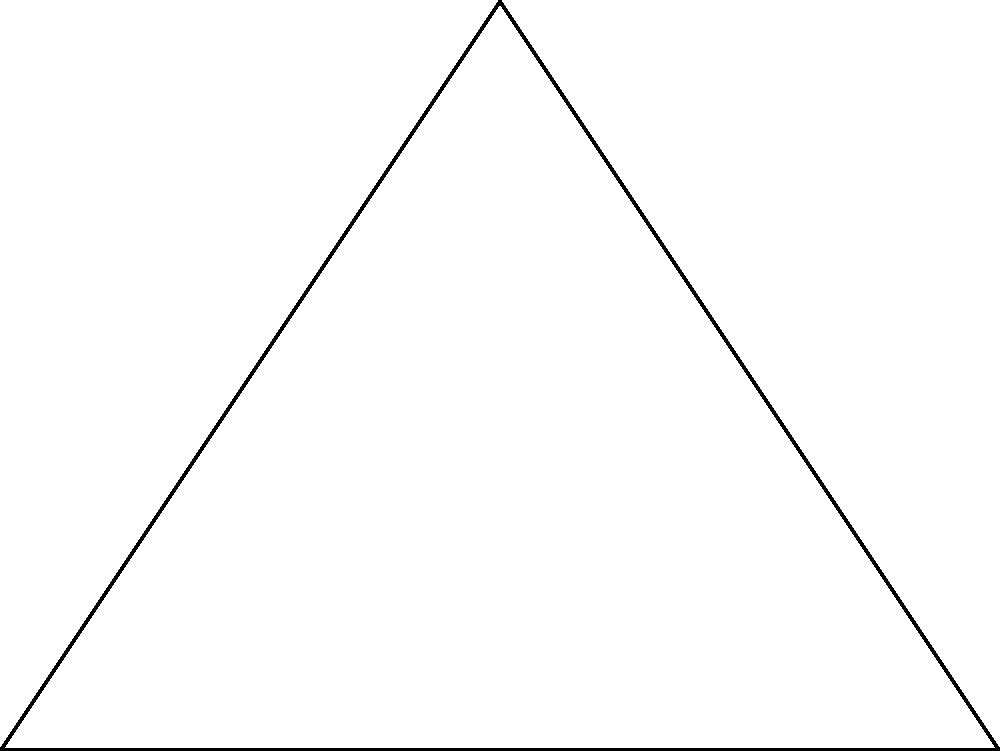In a Luddi dance formation, three dancers form an equilateral triangle ABC with side length 4 units. The centroid of the triangle is point D. If the dancers rotate around their positions to form circles with radius 1 unit, what is the area of the region that is covered by all three circular paths but not by the triangle ABC? Let's approach this step-by-step:

1) First, we need to calculate the area of the equilateral triangle ABC.
   Area of equilateral triangle = $\frac{\sqrt{3}}{4}a^2$, where $a$ is the side length.
   Area of ABC = $\frac{\sqrt{3}}{4}(4^2) = 4\sqrt{3}$ square units.

2) Next, we need to find the area of each circular sector that falls outside the triangle.
   To do this, we need to find the angle of the sector.
   In an equilateral triangle, each angle is 60°.
   The sector angle is therefore 360° - 60° = 300° = $\frac{5\pi}{3}$ radians.

3) Area of a sector = $\frac{\theta}{2\pi}r^2$, where $\theta$ is the angle in radians and $r$ is the radius.
   Area of each sector = $\frac{\frac{5\pi}{3}}{2\pi}(1^2) = \frac{5}{6}$ square units.

4) The area outside the triangle covered by each circle is the sector area minus the area of the equilateral triangle formed by the center of the circle and two vertices of the original triangle.
   Area of small equilateral triangle = $\frac{\sqrt{3}}{4}(1^2) = \frac{\sqrt{3}}{4}$ square units.

5) Area covered by each circle outside ABC = $\frac{5}{6} - \frac{\sqrt{3}}{4}$ square units.

6) There are three such areas, so the total area covered by the circles outside ABC is:
   $3(\frac{5}{6} - \frac{\sqrt{3}}{4}) = \frac{5}{2} - \frac{3\sqrt{3}}{4}$ square units.

7) This is the area covered by the circles but not by the triangle ABC.
Answer: $\frac{5}{2} - \frac{3\sqrt{3}}{4}$ square units 